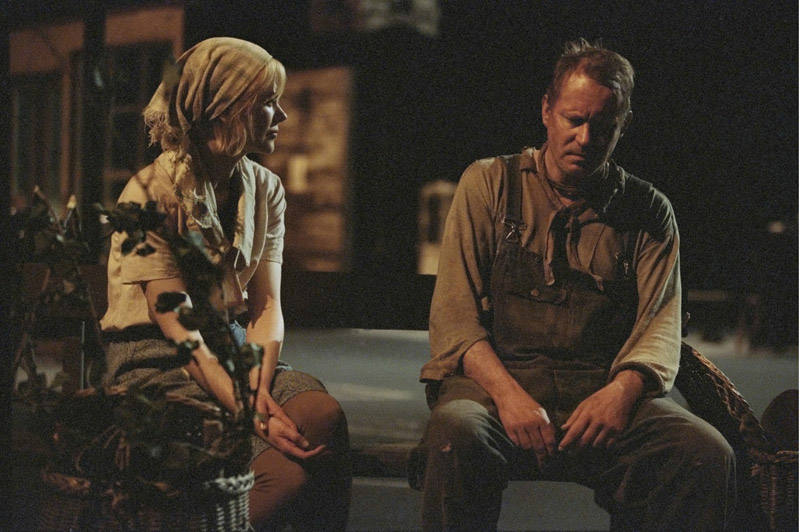Can you craft a short story based on this image? In a small village, where the whispers of the wind carried tales of old, sat Edgar, the village’s most dedicated farmer. Years of toiling the land had etched deep lines across his face, each wrinkle telling a story of resilience and hardship. Today, he found himself lost in thought, hands clasped, as he sat on the old wooden bench in front of his modest farmhouse. Agnes, his only daughter, kneeled beside him. Her heart ached seeing her father's sorrow. The recent drought had devastated their crops, and they faced uncertainty and potential ruin. But deep in her eyes was determination, a will to fight for their legacy. 'We’ll find a way, Papa,' she gently reassured him, her voice barely a whisper but filled with resolve. Edgar looked at her, his eyes betraying a glimmer of hope amidst the shadows of despair. Together, they would brave the storm, just as they always had. Imagine this scene set in a fantastical world. How would it differ? In the enchanted land of Eldoria, where magic flowed through every leaf and stone, sat Thendril, a revered sorcerer, on an ancient wooden bench beset with runes of power. His robes, once shimmering with mystical sigils, were now faded, much like his spirits. By his side, kneeling on the moss-covered ground, was Elara, a young mage adorned in blue and white robes, her eyes holding both concern and fierce determination. They faced a grave challenge; the magical wellspring that sustained their realm was drying up, its life-giving essence dwindling. As Thendril pondered over ancient tomes and prophecies, Elara’s hands glowed softly with nascent spells, her resolve unwavering. 'We will restore the wellspring, Master,' she proclaimed, her voice echoing with the promise of untapped potential. Thendril’s gaze softened; in Elara’s youthful resolve, he saw the hope for Eldoria’s future. Together, they would harness the arcane arts and embark on a perilous journey to save their world. 